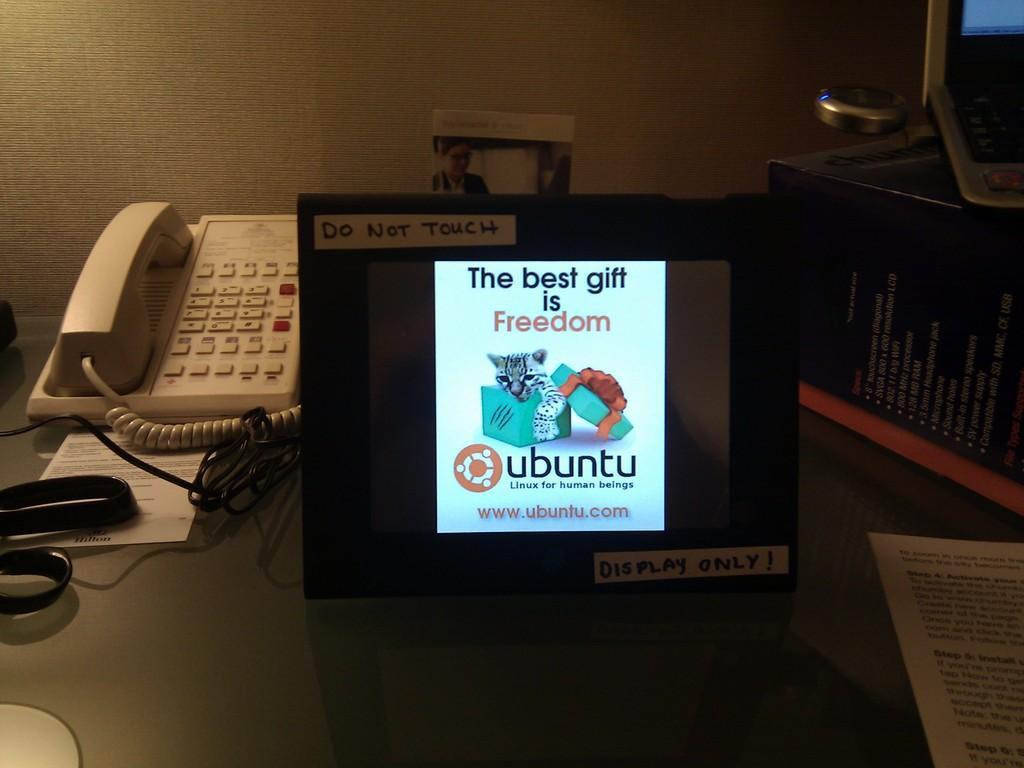Please provide a concise description of this image. In the image we can see this is a display, paper, cable wire, scissor, telephone, poster and other device, this is a box. 